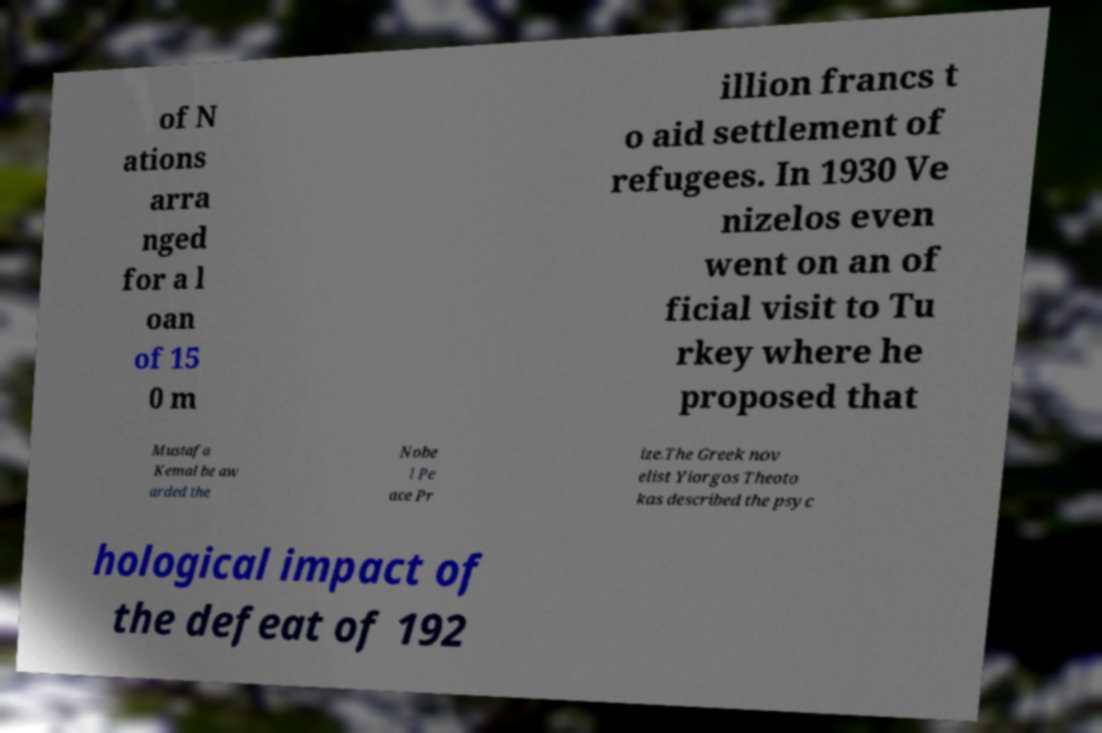For documentation purposes, I need the text within this image transcribed. Could you provide that? of N ations arra nged for a l oan of 15 0 m illion francs t o aid settlement of refugees. In 1930 Ve nizelos even went on an of ficial visit to Tu rkey where he proposed that Mustafa Kemal be aw arded the Nobe l Pe ace Pr ize.The Greek nov elist Yiorgos Theoto kas described the psyc hological impact of the defeat of 192 